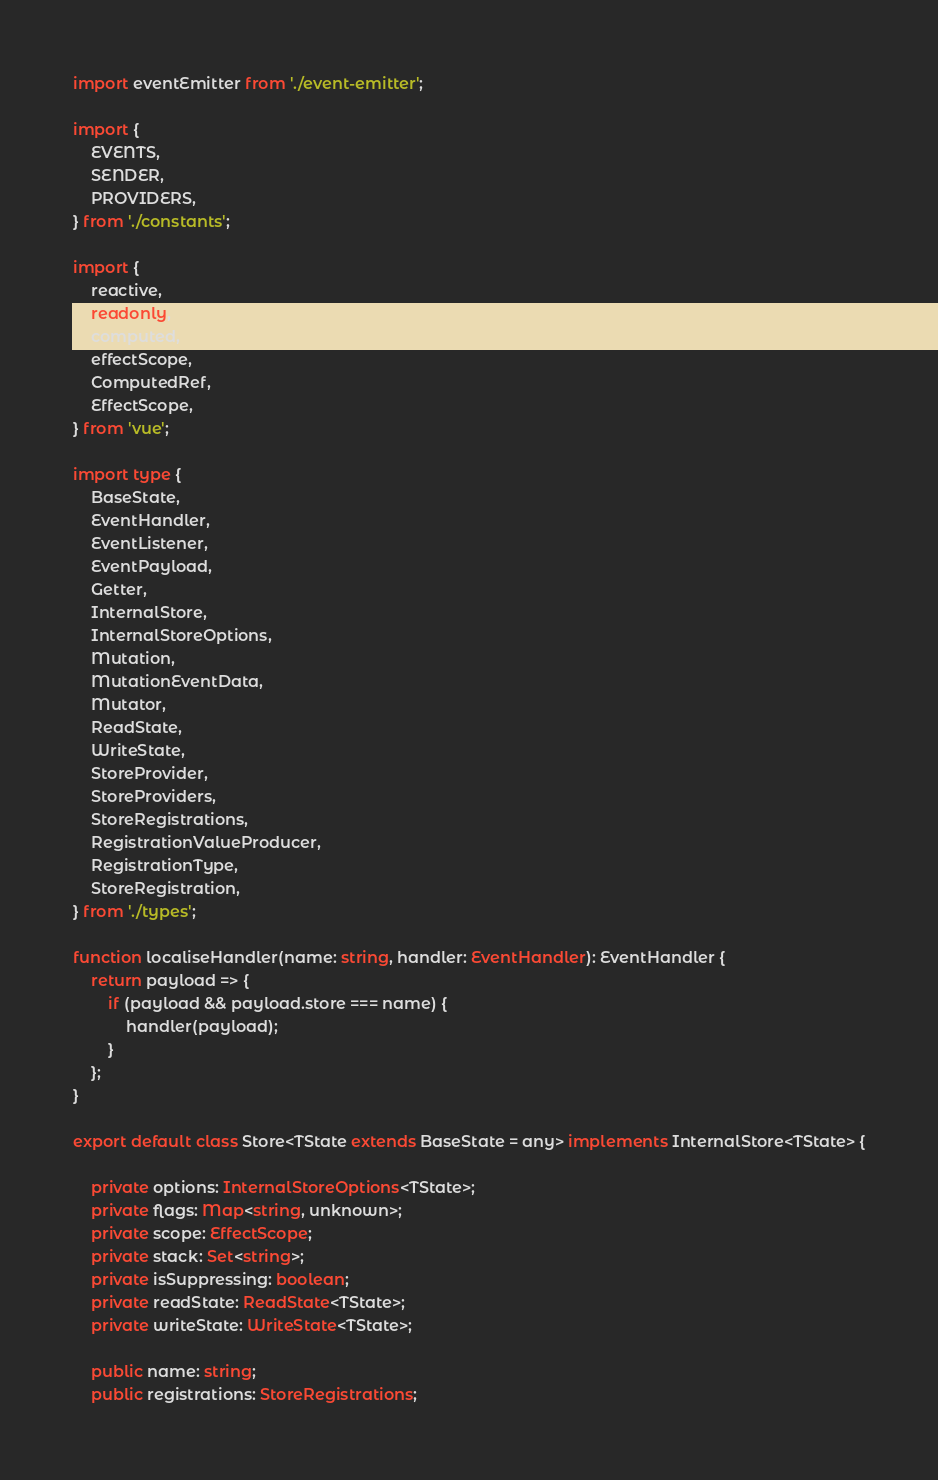Convert code to text. <code><loc_0><loc_0><loc_500><loc_500><_TypeScript_>import eventEmitter from './event-emitter';

import {
    EVENTS,
    SENDER,
    PROVIDERS,
} from './constants';

import {
    reactive,
    readonly,
    computed,
    effectScope,
    ComputedRef,
    EffectScope,
} from 'vue';

import type {
    BaseState,
    EventHandler,
    EventListener,
    EventPayload,
    Getter,
    InternalStore,
    InternalStoreOptions,
    Mutation,
    MutationEventData,
    Mutator,
    ReadState,
    WriteState,
    StoreProvider,
    StoreProviders,
    StoreRegistrations,
    RegistrationValueProducer,
    RegistrationType,
    StoreRegistration,
} from './types';

function localiseHandler(name: string, handler: EventHandler): EventHandler {
    return payload => {
        if (payload && payload.store === name) {
            handler(payload);
        }
    };
}

export default class Store<TState extends BaseState = any> implements InternalStore<TState> {

    private options: InternalStoreOptions<TState>;
    private flags: Map<string, unknown>;
    private scope: EffectScope;
    private stack: Set<string>;
    private isSuppressing: boolean;
    private readState: ReadState<TState>;
    private writeState: WriteState<TState>;

    public name: string;
    public registrations: StoreRegistrations;
</code> 